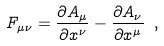Convert formula to latex. <formula><loc_0><loc_0><loc_500><loc_500>F _ { \mu \nu } = \frac { \partial A _ { \mu } } { \partial x ^ { \nu } } - \frac { \partial A _ { \nu } } { \partial x ^ { \mu } } \ ,</formula> 